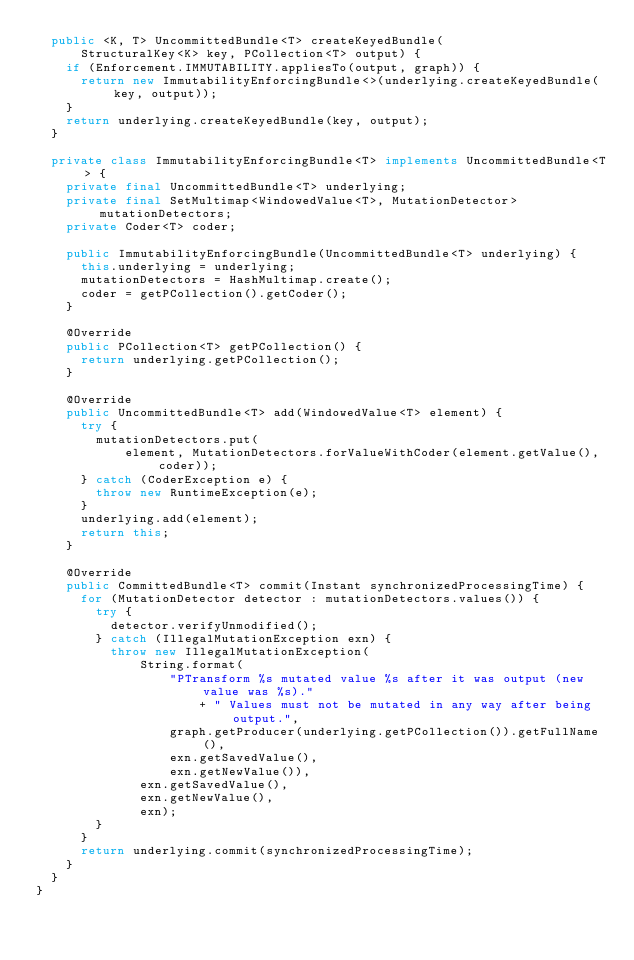<code> <loc_0><loc_0><loc_500><loc_500><_Java_>  public <K, T> UncommittedBundle<T> createKeyedBundle(
      StructuralKey<K> key, PCollection<T> output) {
    if (Enforcement.IMMUTABILITY.appliesTo(output, graph)) {
      return new ImmutabilityEnforcingBundle<>(underlying.createKeyedBundle(key, output));
    }
    return underlying.createKeyedBundle(key, output);
  }

  private class ImmutabilityEnforcingBundle<T> implements UncommittedBundle<T> {
    private final UncommittedBundle<T> underlying;
    private final SetMultimap<WindowedValue<T>, MutationDetector> mutationDetectors;
    private Coder<T> coder;

    public ImmutabilityEnforcingBundle(UncommittedBundle<T> underlying) {
      this.underlying = underlying;
      mutationDetectors = HashMultimap.create();
      coder = getPCollection().getCoder();
    }

    @Override
    public PCollection<T> getPCollection() {
      return underlying.getPCollection();
    }

    @Override
    public UncommittedBundle<T> add(WindowedValue<T> element) {
      try {
        mutationDetectors.put(
            element, MutationDetectors.forValueWithCoder(element.getValue(), coder));
      } catch (CoderException e) {
        throw new RuntimeException(e);
      }
      underlying.add(element);
      return this;
    }

    @Override
    public CommittedBundle<T> commit(Instant synchronizedProcessingTime) {
      for (MutationDetector detector : mutationDetectors.values()) {
        try {
          detector.verifyUnmodified();
        } catch (IllegalMutationException exn) {
          throw new IllegalMutationException(
              String.format(
                  "PTransform %s mutated value %s after it was output (new value was %s)."
                      + " Values must not be mutated in any way after being output.",
                  graph.getProducer(underlying.getPCollection()).getFullName(),
                  exn.getSavedValue(),
                  exn.getNewValue()),
              exn.getSavedValue(),
              exn.getNewValue(),
              exn);
        }
      }
      return underlying.commit(synchronizedProcessingTime);
    }
  }
}
</code> 